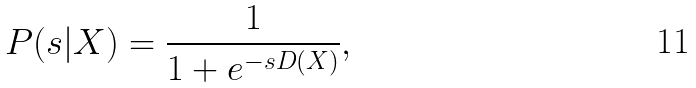<formula> <loc_0><loc_0><loc_500><loc_500>P ( s | X ) = \frac { 1 } { 1 + e ^ { - s D ( X ) } } ,</formula> 